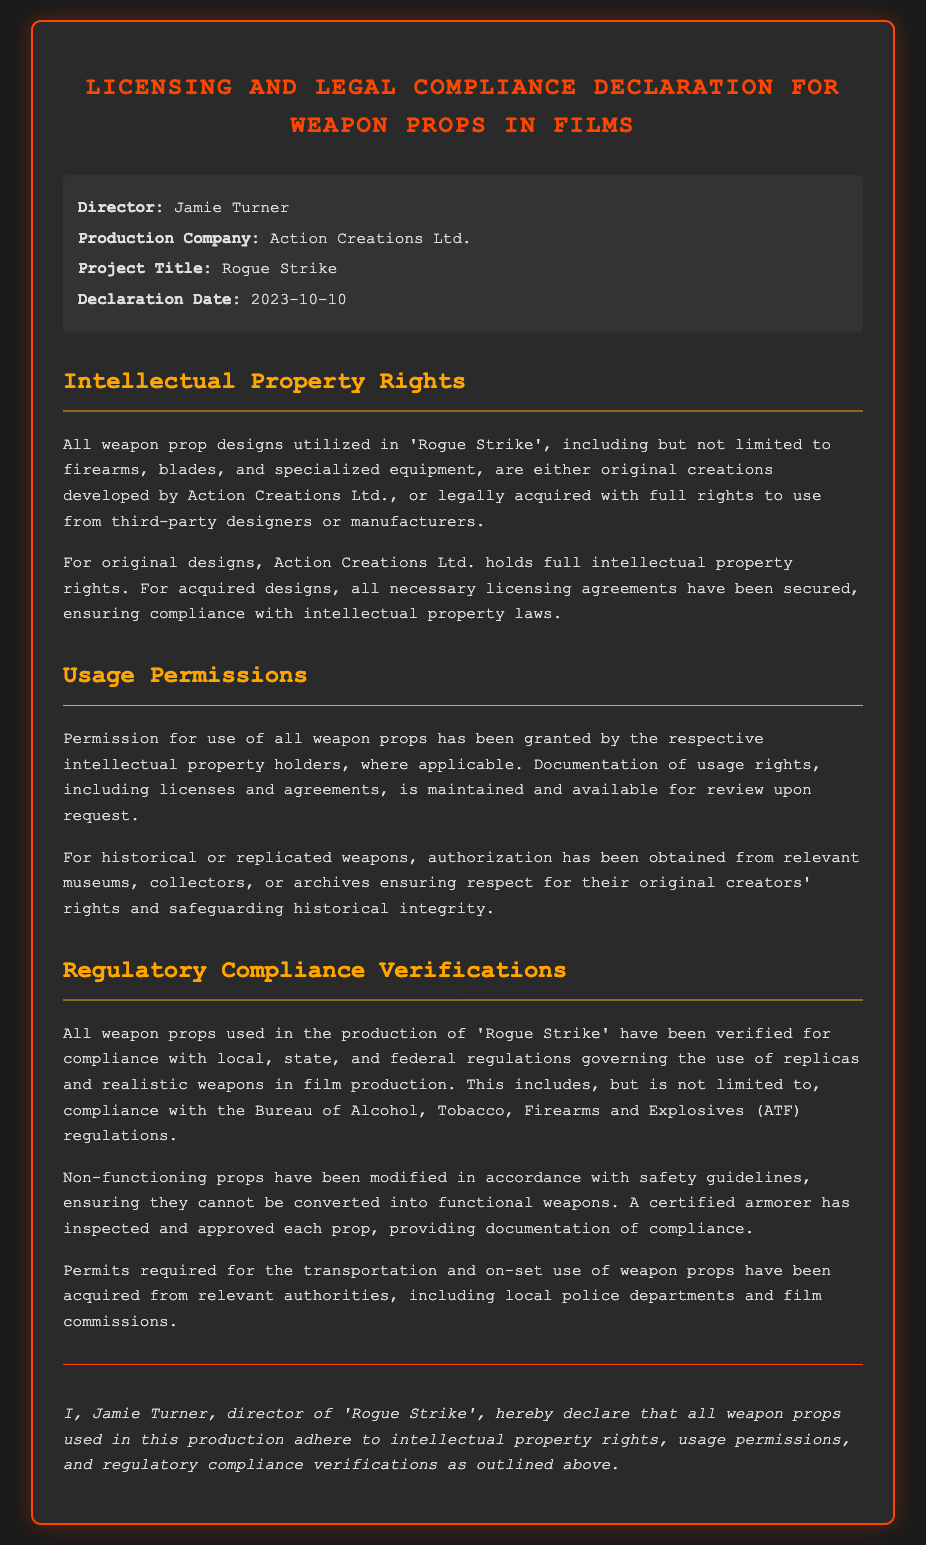What is the director's name? The director's name is mentioned in the meta-info section of the document.
Answer: Jamie Turner What is the production company? The production company is specified in the meta-info section.
Answer: Action Creations Ltd What is the project title? The project title is provided in the document's meta-info section.
Answer: Rogue Strike When was the declaration made? The declaration date is included in the meta-info section of the document.
Answer: 2023-10-10 Who holds the intellectual property rights for original designs? The document states that original designs are held by a specific entity.
Answer: Action Creations Ltd What must be obtained for historical weapons? The document specifies what is needed for the usage of historical or replicated weapons.
Answer: Authorization What department regulates the use of replicas in film? The document mentions a specific regulatory body for compliance in film productions.
Answer: Bureau of Alcohol, Tobacco, Firearms and Explosives (ATF) Who inspected and approved the weapon props? The document states who is responsible for inspecting the props.
Answer: Certified armorer What is the nature of the props mentioned? The document specifies whether the props are functional or non-functional.
Answer: Non-functioning 